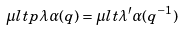Convert formula to latex. <formula><loc_0><loc_0><loc_500><loc_500>\mu l t p \lambda { \alpha ( q ) } = \mu l t { \lambda ^ { \prime } } { \alpha ( q ^ { - 1 } ) }</formula> 